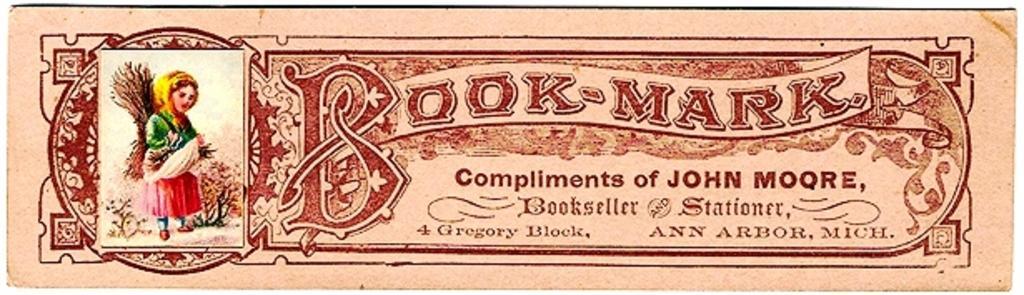Describe this image in one or two sentences. In this image we can see poster with a picture and some text on it. 